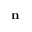Convert formula to latex. <formula><loc_0><loc_0><loc_500><loc_500>n</formula> 